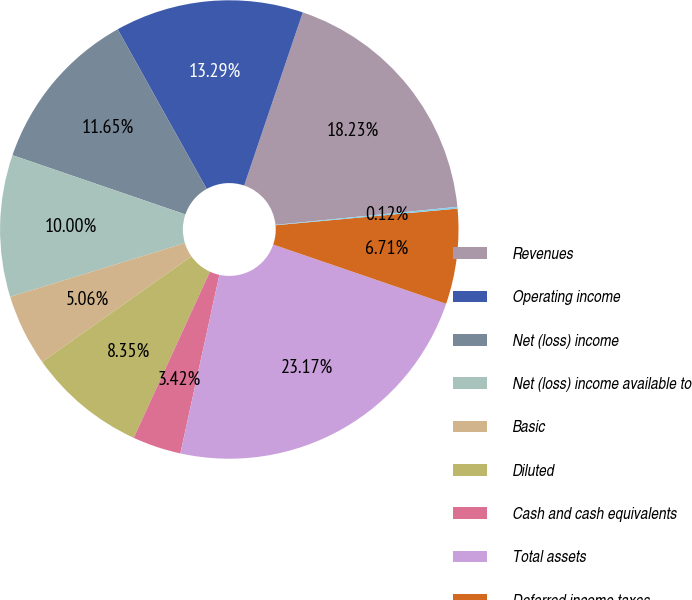Convert chart to OTSL. <chart><loc_0><loc_0><loc_500><loc_500><pie_chart><fcel>Revenues<fcel>Operating income<fcel>Net (loss) income<fcel>Net (loss) income available to<fcel>Basic<fcel>Diluted<fcel>Cash and cash equivalents<fcel>Total assets<fcel>Deferred income taxes<fcel>Current portion<nl><fcel>18.23%<fcel>13.29%<fcel>11.65%<fcel>10.0%<fcel>5.06%<fcel>8.35%<fcel>3.42%<fcel>23.17%<fcel>6.71%<fcel>0.12%<nl></chart> 